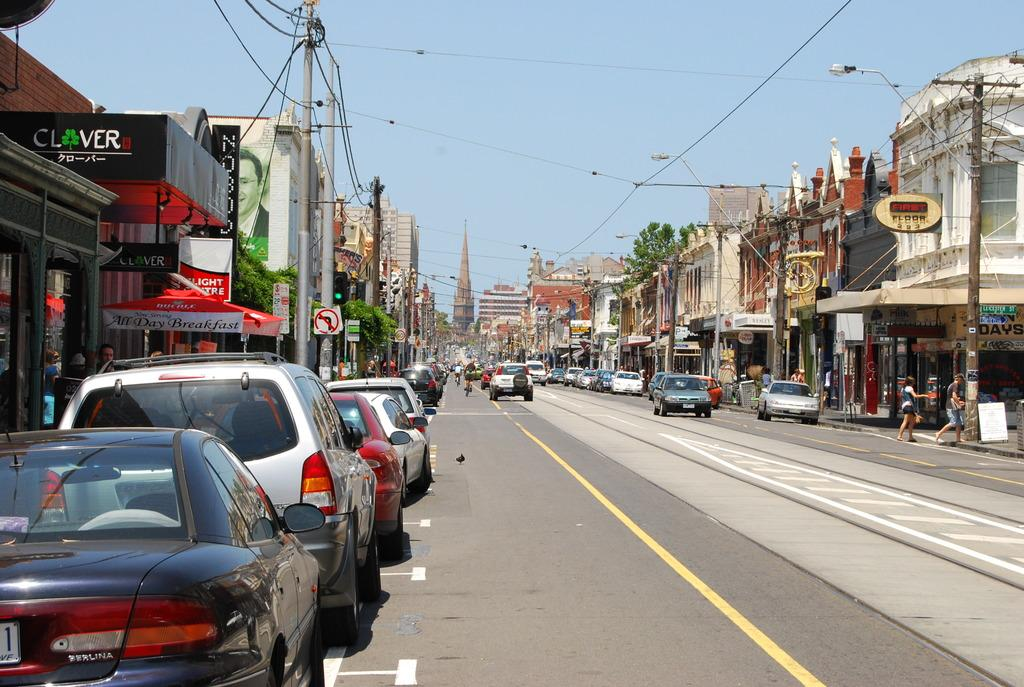<image>
Create a compact narrative representing the image presented. A street with many parked cars and businesses like one called Clover and another called First Floor. 